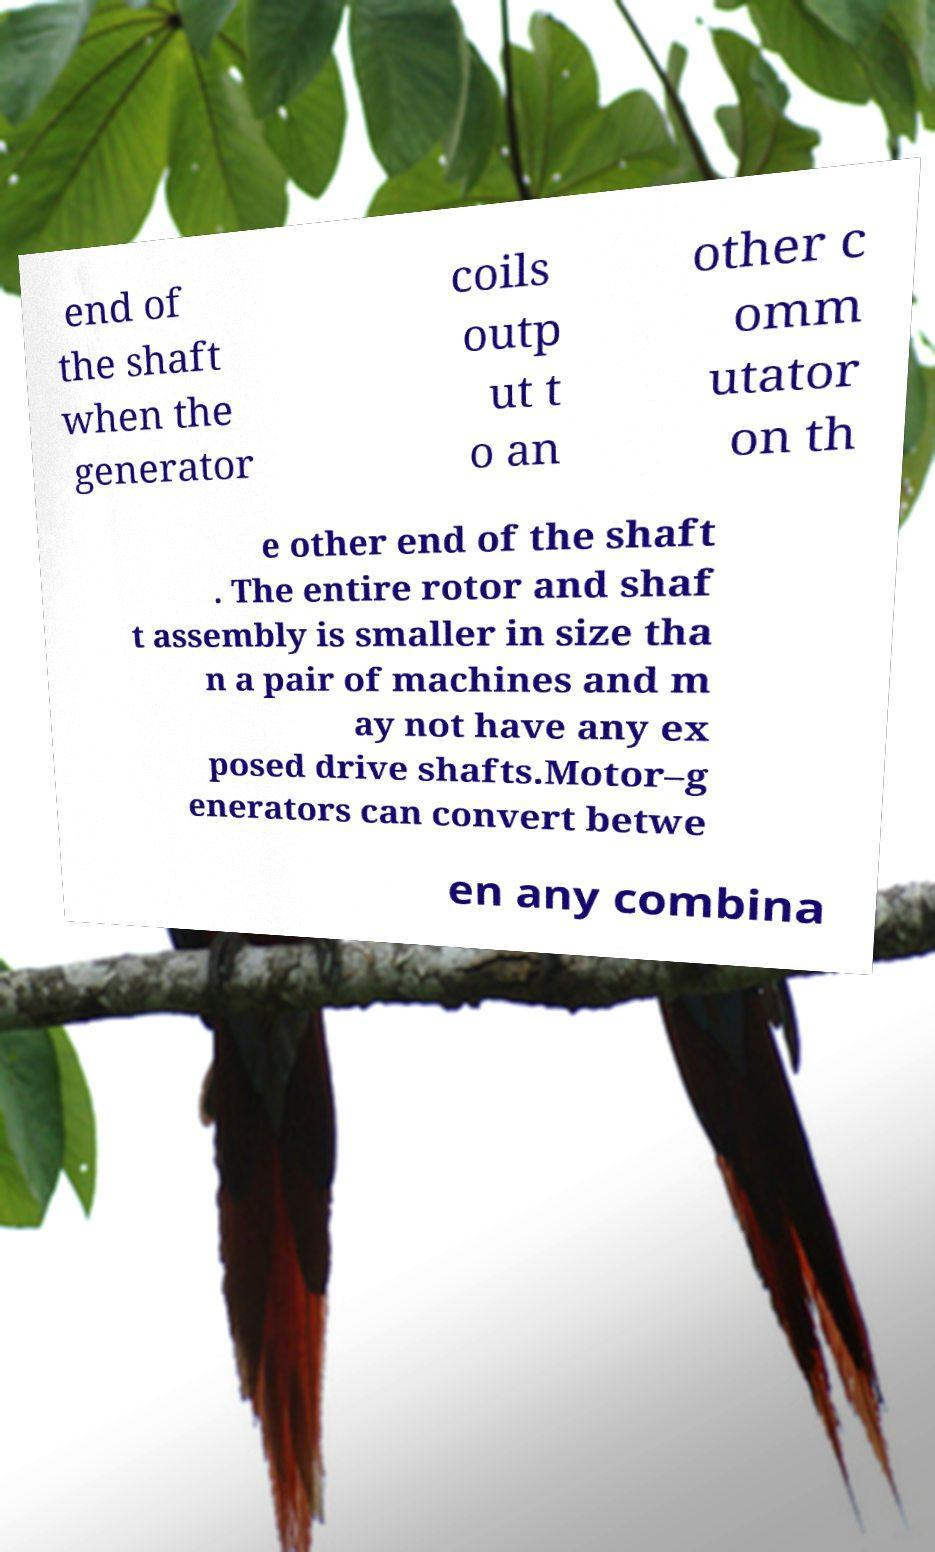Can you accurately transcribe the text from the provided image for me? end of the shaft when the generator coils outp ut t o an other c omm utator on th e other end of the shaft . The entire rotor and shaf t assembly is smaller in size tha n a pair of machines and m ay not have any ex posed drive shafts.Motor–g enerators can convert betwe en any combina 